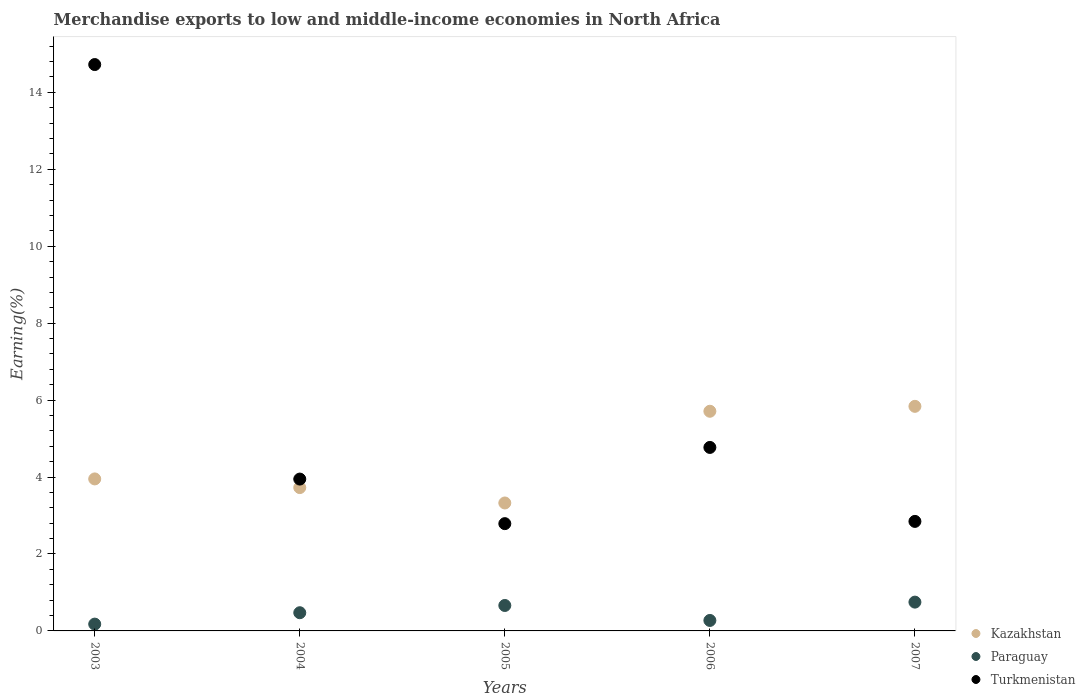What is the percentage of amount earned from merchandise exports in Paraguay in 2006?
Offer a very short reply. 0.27. Across all years, what is the maximum percentage of amount earned from merchandise exports in Turkmenistan?
Keep it short and to the point. 14.72. Across all years, what is the minimum percentage of amount earned from merchandise exports in Turkmenistan?
Your answer should be very brief. 2.79. In which year was the percentage of amount earned from merchandise exports in Kazakhstan maximum?
Make the answer very short. 2007. What is the total percentage of amount earned from merchandise exports in Turkmenistan in the graph?
Provide a short and direct response. 29.08. What is the difference between the percentage of amount earned from merchandise exports in Kazakhstan in 2004 and that in 2006?
Your answer should be very brief. -1.98. What is the difference between the percentage of amount earned from merchandise exports in Paraguay in 2004 and the percentage of amount earned from merchandise exports in Kazakhstan in 2005?
Your answer should be very brief. -2.85. What is the average percentage of amount earned from merchandise exports in Paraguay per year?
Make the answer very short. 0.47. In the year 2007, what is the difference between the percentage of amount earned from merchandise exports in Kazakhstan and percentage of amount earned from merchandise exports in Paraguay?
Your answer should be very brief. 5.09. In how many years, is the percentage of amount earned from merchandise exports in Kazakhstan greater than 5.2 %?
Provide a short and direct response. 2. What is the ratio of the percentage of amount earned from merchandise exports in Paraguay in 2003 to that in 2007?
Ensure brevity in your answer.  0.24. Is the difference between the percentage of amount earned from merchandise exports in Kazakhstan in 2003 and 2006 greater than the difference between the percentage of amount earned from merchandise exports in Paraguay in 2003 and 2006?
Offer a terse response. No. What is the difference between the highest and the second highest percentage of amount earned from merchandise exports in Paraguay?
Ensure brevity in your answer.  0.09. What is the difference between the highest and the lowest percentage of amount earned from merchandise exports in Paraguay?
Offer a terse response. 0.57. In how many years, is the percentage of amount earned from merchandise exports in Kazakhstan greater than the average percentage of amount earned from merchandise exports in Kazakhstan taken over all years?
Your response must be concise. 2. Is it the case that in every year, the sum of the percentage of amount earned from merchandise exports in Paraguay and percentage of amount earned from merchandise exports in Kazakhstan  is greater than the percentage of amount earned from merchandise exports in Turkmenistan?
Your answer should be very brief. No. How many years are there in the graph?
Your answer should be compact. 5. What is the difference between two consecutive major ticks on the Y-axis?
Provide a succinct answer. 2. Does the graph contain any zero values?
Your answer should be compact. No. How are the legend labels stacked?
Provide a succinct answer. Vertical. What is the title of the graph?
Provide a succinct answer. Merchandise exports to low and middle-income economies in North Africa. Does "Seychelles" appear as one of the legend labels in the graph?
Your answer should be compact. No. What is the label or title of the X-axis?
Provide a short and direct response. Years. What is the label or title of the Y-axis?
Offer a very short reply. Earning(%). What is the Earning(%) in Kazakhstan in 2003?
Your answer should be very brief. 3.95. What is the Earning(%) of Paraguay in 2003?
Offer a terse response. 0.18. What is the Earning(%) of Turkmenistan in 2003?
Provide a succinct answer. 14.72. What is the Earning(%) in Kazakhstan in 2004?
Make the answer very short. 3.73. What is the Earning(%) of Paraguay in 2004?
Keep it short and to the point. 0.47. What is the Earning(%) of Turkmenistan in 2004?
Your response must be concise. 3.95. What is the Earning(%) in Kazakhstan in 2005?
Make the answer very short. 3.33. What is the Earning(%) in Paraguay in 2005?
Ensure brevity in your answer.  0.66. What is the Earning(%) of Turkmenistan in 2005?
Your answer should be compact. 2.79. What is the Earning(%) of Kazakhstan in 2006?
Your response must be concise. 5.71. What is the Earning(%) in Paraguay in 2006?
Give a very brief answer. 0.27. What is the Earning(%) in Turkmenistan in 2006?
Keep it short and to the point. 4.77. What is the Earning(%) of Kazakhstan in 2007?
Give a very brief answer. 5.84. What is the Earning(%) in Paraguay in 2007?
Your answer should be very brief. 0.75. What is the Earning(%) in Turkmenistan in 2007?
Keep it short and to the point. 2.85. Across all years, what is the maximum Earning(%) of Kazakhstan?
Give a very brief answer. 5.84. Across all years, what is the maximum Earning(%) of Paraguay?
Your response must be concise. 0.75. Across all years, what is the maximum Earning(%) of Turkmenistan?
Ensure brevity in your answer.  14.72. Across all years, what is the minimum Earning(%) in Kazakhstan?
Offer a terse response. 3.33. Across all years, what is the minimum Earning(%) in Paraguay?
Give a very brief answer. 0.18. Across all years, what is the minimum Earning(%) of Turkmenistan?
Provide a succinct answer. 2.79. What is the total Earning(%) in Kazakhstan in the graph?
Offer a terse response. 22.55. What is the total Earning(%) of Paraguay in the graph?
Keep it short and to the point. 2.33. What is the total Earning(%) of Turkmenistan in the graph?
Provide a short and direct response. 29.08. What is the difference between the Earning(%) of Kazakhstan in 2003 and that in 2004?
Provide a short and direct response. 0.23. What is the difference between the Earning(%) in Paraguay in 2003 and that in 2004?
Ensure brevity in your answer.  -0.3. What is the difference between the Earning(%) of Turkmenistan in 2003 and that in 2004?
Your answer should be very brief. 10.78. What is the difference between the Earning(%) of Kazakhstan in 2003 and that in 2005?
Provide a succinct answer. 0.63. What is the difference between the Earning(%) in Paraguay in 2003 and that in 2005?
Offer a very short reply. -0.48. What is the difference between the Earning(%) of Turkmenistan in 2003 and that in 2005?
Keep it short and to the point. 11.93. What is the difference between the Earning(%) in Kazakhstan in 2003 and that in 2006?
Keep it short and to the point. -1.76. What is the difference between the Earning(%) of Paraguay in 2003 and that in 2006?
Your response must be concise. -0.1. What is the difference between the Earning(%) in Turkmenistan in 2003 and that in 2006?
Your answer should be compact. 9.95. What is the difference between the Earning(%) in Kazakhstan in 2003 and that in 2007?
Provide a succinct answer. -1.89. What is the difference between the Earning(%) of Paraguay in 2003 and that in 2007?
Make the answer very short. -0.57. What is the difference between the Earning(%) of Turkmenistan in 2003 and that in 2007?
Provide a short and direct response. 11.88. What is the difference between the Earning(%) in Kazakhstan in 2004 and that in 2005?
Provide a short and direct response. 0.4. What is the difference between the Earning(%) in Paraguay in 2004 and that in 2005?
Provide a short and direct response. -0.19. What is the difference between the Earning(%) in Turkmenistan in 2004 and that in 2005?
Ensure brevity in your answer.  1.16. What is the difference between the Earning(%) of Kazakhstan in 2004 and that in 2006?
Provide a short and direct response. -1.98. What is the difference between the Earning(%) of Paraguay in 2004 and that in 2006?
Your response must be concise. 0.2. What is the difference between the Earning(%) in Turkmenistan in 2004 and that in 2006?
Offer a very short reply. -0.82. What is the difference between the Earning(%) in Kazakhstan in 2004 and that in 2007?
Your answer should be very brief. -2.11. What is the difference between the Earning(%) in Paraguay in 2004 and that in 2007?
Keep it short and to the point. -0.28. What is the difference between the Earning(%) in Turkmenistan in 2004 and that in 2007?
Offer a very short reply. 1.1. What is the difference between the Earning(%) in Kazakhstan in 2005 and that in 2006?
Make the answer very short. -2.38. What is the difference between the Earning(%) of Paraguay in 2005 and that in 2006?
Your answer should be compact. 0.39. What is the difference between the Earning(%) in Turkmenistan in 2005 and that in 2006?
Provide a short and direct response. -1.98. What is the difference between the Earning(%) of Kazakhstan in 2005 and that in 2007?
Provide a short and direct response. -2.51. What is the difference between the Earning(%) of Paraguay in 2005 and that in 2007?
Ensure brevity in your answer.  -0.09. What is the difference between the Earning(%) of Turkmenistan in 2005 and that in 2007?
Ensure brevity in your answer.  -0.06. What is the difference between the Earning(%) in Kazakhstan in 2006 and that in 2007?
Your answer should be compact. -0.13. What is the difference between the Earning(%) of Paraguay in 2006 and that in 2007?
Your response must be concise. -0.48. What is the difference between the Earning(%) in Turkmenistan in 2006 and that in 2007?
Keep it short and to the point. 1.92. What is the difference between the Earning(%) of Kazakhstan in 2003 and the Earning(%) of Paraguay in 2004?
Your answer should be compact. 3.48. What is the difference between the Earning(%) in Kazakhstan in 2003 and the Earning(%) in Turkmenistan in 2004?
Your response must be concise. 0. What is the difference between the Earning(%) in Paraguay in 2003 and the Earning(%) in Turkmenistan in 2004?
Keep it short and to the point. -3.77. What is the difference between the Earning(%) of Kazakhstan in 2003 and the Earning(%) of Paraguay in 2005?
Your answer should be very brief. 3.29. What is the difference between the Earning(%) of Kazakhstan in 2003 and the Earning(%) of Turkmenistan in 2005?
Give a very brief answer. 1.16. What is the difference between the Earning(%) of Paraguay in 2003 and the Earning(%) of Turkmenistan in 2005?
Your response must be concise. -2.61. What is the difference between the Earning(%) in Kazakhstan in 2003 and the Earning(%) in Paraguay in 2006?
Offer a terse response. 3.68. What is the difference between the Earning(%) of Kazakhstan in 2003 and the Earning(%) of Turkmenistan in 2006?
Make the answer very short. -0.82. What is the difference between the Earning(%) of Paraguay in 2003 and the Earning(%) of Turkmenistan in 2006?
Offer a very short reply. -4.59. What is the difference between the Earning(%) of Kazakhstan in 2003 and the Earning(%) of Paraguay in 2007?
Your response must be concise. 3.2. What is the difference between the Earning(%) of Kazakhstan in 2003 and the Earning(%) of Turkmenistan in 2007?
Ensure brevity in your answer.  1.1. What is the difference between the Earning(%) of Paraguay in 2003 and the Earning(%) of Turkmenistan in 2007?
Offer a terse response. -2.67. What is the difference between the Earning(%) of Kazakhstan in 2004 and the Earning(%) of Paraguay in 2005?
Ensure brevity in your answer.  3.06. What is the difference between the Earning(%) in Kazakhstan in 2004 and the Earning(%) in Turkmenistan in 2005?
Your response must be concise. 0.94. What is the difference between the Earning(%) in Paraguay in 2004 and the Earning(%) in Turkmenistan in 2005?
Your answer should be compact. -2.32. What is the difference between the Earning(%) of Kazakhstan in 2004 and the Earning(%) of Paraguay in 2006?
Keep it short and to the point. 3.45. What is the difference between the Earning(%) in Kazakhstan in 2004 and the Earning(%) in Turkmenistan in 2006?
Ensure brevity in your answer.  -1.04. What is the difference between the Earning(%) of Paraguay in 2004 and the Earning(%) of Turkmenistan in 2006?
Offer a terse response. -4.3. What is the difference between the Earning(%) in Kazakhstan in 2004 and the Earning(%) in Paraguay in 2007?
Provide a short and direct response. 2.98. What is the difference between the Earning(%) of Kazakhstan in 2004 and the Earning(%) of Turkmenistan in 2007?
Offer a terse response. 0.88. What is the difference between the Earning(%) in Paraguay in 2004 and the Earning(%) in Turkmenistan in 2007?
Offer a very short reply. -2.37. What is the difference between the Earning(%) in Kazakhstan in 2005 and the Earning(%) in Paraguay in 2006?
Make the answer very short. 3.05. What is the difference between the Earning(%) of Kazakhstan in 2005 and the Earning(%) of Turkmenistan in 2006?
Offer a very short reply. -1.44. What is the difference between the Earning(%) of Paraguay in 2005 and the Earning(%) of Turkmenistan in 2006?
Offer a terse response. -4.11. What is the difference between the Earning(%) in Kazakhstan in 2005 and the Earning(%) in Paraguay in 2007?
Give a very brief answer. 2.58. What is the difference between the Earning(%) of Kazakhstan in 2005 and the Earning(%) of Turkmenistan in 2007?
Provide a succinct answer. 0.48. What is the difference between the Earning(%) in Paraguay in 2005 and the Earning(%) in Turkmenistan in 2007?
Your response must be concise. -2.19. What is the difference between the Earning(%) in Kazakhstan in 2006 and the Earning(%) in Paraguay in 2007?
Your answer should be very brief. 4.96. What is the difference between the Earning(%) of Kazakhstan in 2006 and the Earning(%) of Turkmenistan in 2007?
Provide a succinct answer. 2.86. What is the difference between the Earning(%) of Paraguay in 2006 and the Earning(%) of Turkmenistan in 2007?
Keep it short and to the point. -2.57. What is the average Earning(%) of Kazakhstan per year?
Your answer should be very brief. 4.51. What is the average Earning(%) of Paraguay per year?
Provide a succinct answer. 0.47. What is the average Earning(%) in Turkmenistan per year?
Your response must be concise. 5.82. In the year 2003, what is the difference between the Earning(%) in Kazakhstan and Earning(%) in Paraguay?
Offer a very short reply. 3.77. In the year 2003, what is the difference between the Earning(%) of Kazakhstan and Earning(%) of Turkmenistan?
Give a very brief answer. -10.77. In the year 2003, what is the difference between the Earning(%) of Paraguay and Earning(%) of Turkmenistan?
Provide a short and direct response. -14.55. In the year 2004, what is the difference between the Earning(%) in Kazakhstan and Earning(%) in Paraguay?
Ensure brevity in your answer.  3.25. In the year 2004, what is the difference between the Earning(%) in Kazakhstan and Earning(%) in Turkmenistan?
Make the answer very short. -0.22. In the year 2004, what is the difference between the Earning(%) of Paraguay and Earning(%) of Turkmenistan?
Provide a short and direct response. -3.47. In the year 2005, what is the difference between the Earning(%) of Kazakhstan and Earning(%) of Paraguay?
Your response must be concise. 2.66. In the year 2005, what is the difference between the Earning(%) in Kazakhstan and Earning(%) in Turkmenistan?
Provide a succinct answer. 0.54. In the year 2005, what is the difference between the Earning(%) of Paraguay and Earning(%) of Turkmenistan?
Keep it short and to the point. -2.13. In the year 2006, what is the difference between the Earning(%) in Kazakhstan and Earning(%) in Paraguay?
Provide a succinct answer. 5.44. In the year 2006, what is the difference between the Earning(%) of Kazakhstan and Earning(%) of Turkmenistan?
Provide a succinct answer. 0.94. In the year 2006, what is the difference between the Earning(%) in Paraguay and Earning(%) in Turkmenistan?
Ensure brevity in your answer.  -4.5. In the year 2007, what is the difference between the Earning(%) in Kazakhstan and Earning(%) in Paraguay?
Provide a succinct answer. 5.09. In the year 2007, what is the difference between the Earning(%) of Kazakhstan and Earning(%) of Turkmenistan?
Your answer should be very brief. 2.99. In the year 2007, what is the difference between the Earning(%) of Paraguay and Earning(%) of Turkmenistan?
Your answer should be very brief. -2.1. What is the ratio of the Earning(%) of Kazakhstan in 2003 to that in 2004?
Offer a very short reply. 1.06. What is the ratio of the Earning(%) of Paraguay in 2003 to that in 2004?
Your response must be concise. 0.37. What is the ratio of the Earning(%) of Turkmenistan in 2003 to that in 2004?
Your answer should be very brief. 3.73. What is the ratio of the Earning(%) of Kazakhstan in 2003 to that in 2005?
Give a very brief answer. 1.19. What is the ratio of the Earning(%) in Paraguay in 2003 to that in 2005?
Ensure brevity in your answer.  0.27. What is the ratio of the Earning(%) in Turkmenistan in 2003 to that in 2005?
Ensure brevity in your answer.  5.28. What is the ratio of the Earning(%) of Kazakhstan in 2003 to that in 2006?
Your answer should be compact. 0.69. What is the ratio of the Earning(%) of Paraguay in 2003 to that in 2006?
Ensure brevity in your answer.  0.65. What is the ratio of the Earning(%) of Turkmenistan in 2003 to that in 2006?
Offer a very short reply. 3.09. What is the ratio of the Earning(%) in Kazakhstan in 2003 to that in 2007?
Your answer should be very brief. 0.68. What is the ratio of the Earning(%) in Paraguay in 2003 to that in 2007?
Provide a short and direct response. 0.24. What is the ratio of the Earning(%) in Turkmenistan in 2003 to that in 2007?
Keep it short and to the point. 5.17. What is the ratio of the Earning(%) in Kazakhstan in 2004 to that in 2005?
Offer a very short reply. 1.12. What is the ratio of the Earning(%) in Paraguay in 2004 to that in 2005?
Offer a terse response. 0.72. What is the ratio of the Earning(%) of Turkmenistan in 2004 to that in 2005?
Offer a very short reply. 1.42. What is the ratio of the Earning(%) of Kazakhstan in 2004 to that in 2006?
Keep it short and to the point. 0.65. What is the ratio of the Earning(%) in Paraguay in 2004 to that in 2006?
Your answer should be very brief. 1.74. What is the ratio of the Earning(%) of Turkmenistan in 2004 to that in 2006?
Your response must be concise. 0.83. What is the ratio of the Earning(%) of Kazakhstan in 2004 to that in 2007?
Your response must be concise. 0.64. What is the ratio of the Earning(%) of Paraguay in 2004 to that in 2007?
Provide a short and direct response. 0.63. What is the ratio of the Earning(%) in Turkmenistan in 2004 to that in 2007?
Provide a short and direct response. 1.39. What is the ratio of the Earning(%) in Kazakhstan in 2005 to that in 2006?
Your answer should be compact. 0.58. What is the ratio of the Earning(%) of Paraguay in 2005 to that in 2006?
Your answer should be very brief. 2.43. What is the ratio of the Earning(%) in Turkmenistan in 2005 to that in 2006?
Your response must be concise. 0.58. What is the ratio of the Earning(%) in Kazakhstan in 2005 to that in 2007?
Your answer should be compact. 0.57. What is the ratio of the Earning(%) of Paraguay in 2005 to that in 2007?
Offer a very short reply. 0.88. What is the ratio of the Earning(%) in Turkmenistan in 2005 to that in 2007?
Ensure brevity in your answer.  0.98. What is the ratio of the Earning(%) in Kazakhstan in 2006 to that in 2007?
Your answer should be compact. 0.98. What is the ratio of the Earning(%) in Paraguay in 2006 to that in 2007?
Your answer should be very brief. 0.36. What is the ratio of the Earning(%) of Turkmenistan in 2006 to that in 2007?
Give a very brief answer. 1.68. What is the difference between the highest and the second highest Earning(%) of Kazakhstan?
Your answer should be very brief. 0.13. What is the difference between the highest and the second highest Earning(%) of Paraguay?
Provide a succinct answer. 0.09. What is the difference between the highest and the second highest Earning(%) in Turkmenistan?
Keep it short and to the point. 9.95. What is the difference between the highest and the lowest Earning(%) in Kazakhstan?
Your response must be concise. 2.51. What is the difference between the highest and the lowest Earning(%) of Paraguay?
Your answer should be compact. 0.57. What is the difference between the highest and the lowest Earning(%) in Turkmenistan?
Provide a short and direct response. 11.93. 